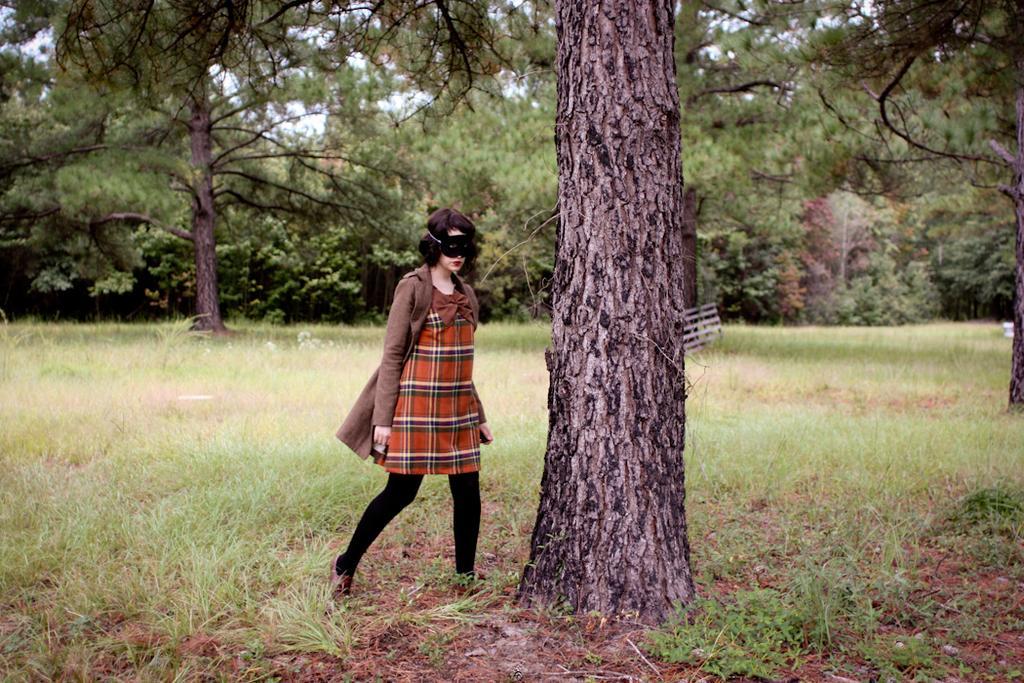In one or two sentences, can you explain what this image depicts? In this picture we can see a woman with the mask. Behind the women there are trees, grass and the sky. 